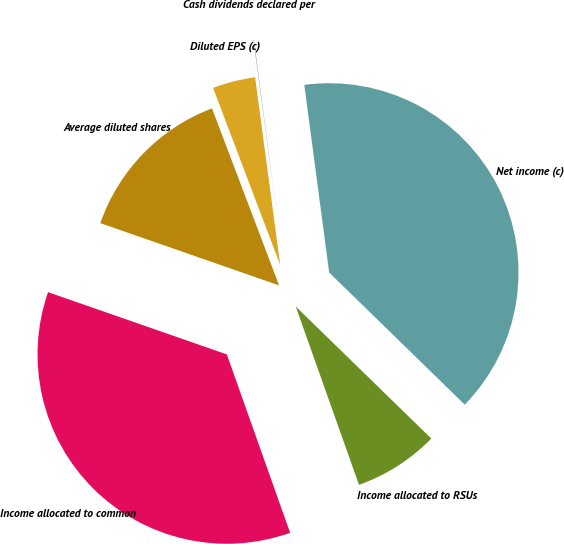Convert chart to OTSL. <chart><loc_0><loc_0><loc_500><loc_500><pie_chart><fcel>Net income (c)<fcel>Income allocated to RSUs<fcel>Income allocated to common<fcel>Average diluted shares<fcel>Diluted EPS (c)<fcel>Cash dividends declared per<nl><fcel>39.39%<fcel>7.28%<fcel>35.76%<fcel>13.9%<fcel>3.65%<fcel>0.02%<nl></chart> 